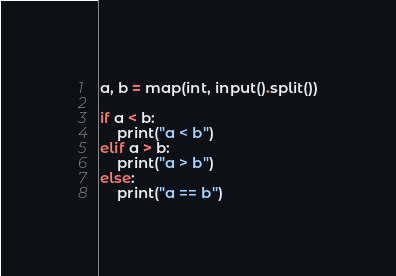<code> <loc_0><loc_0><loc_500><loc_500><_Python_>a, b = map(int, input().split())

if a < b:
    print("a < b")
elif a > b:
    print("a > b")
else:
    print("a == b")
</code> 